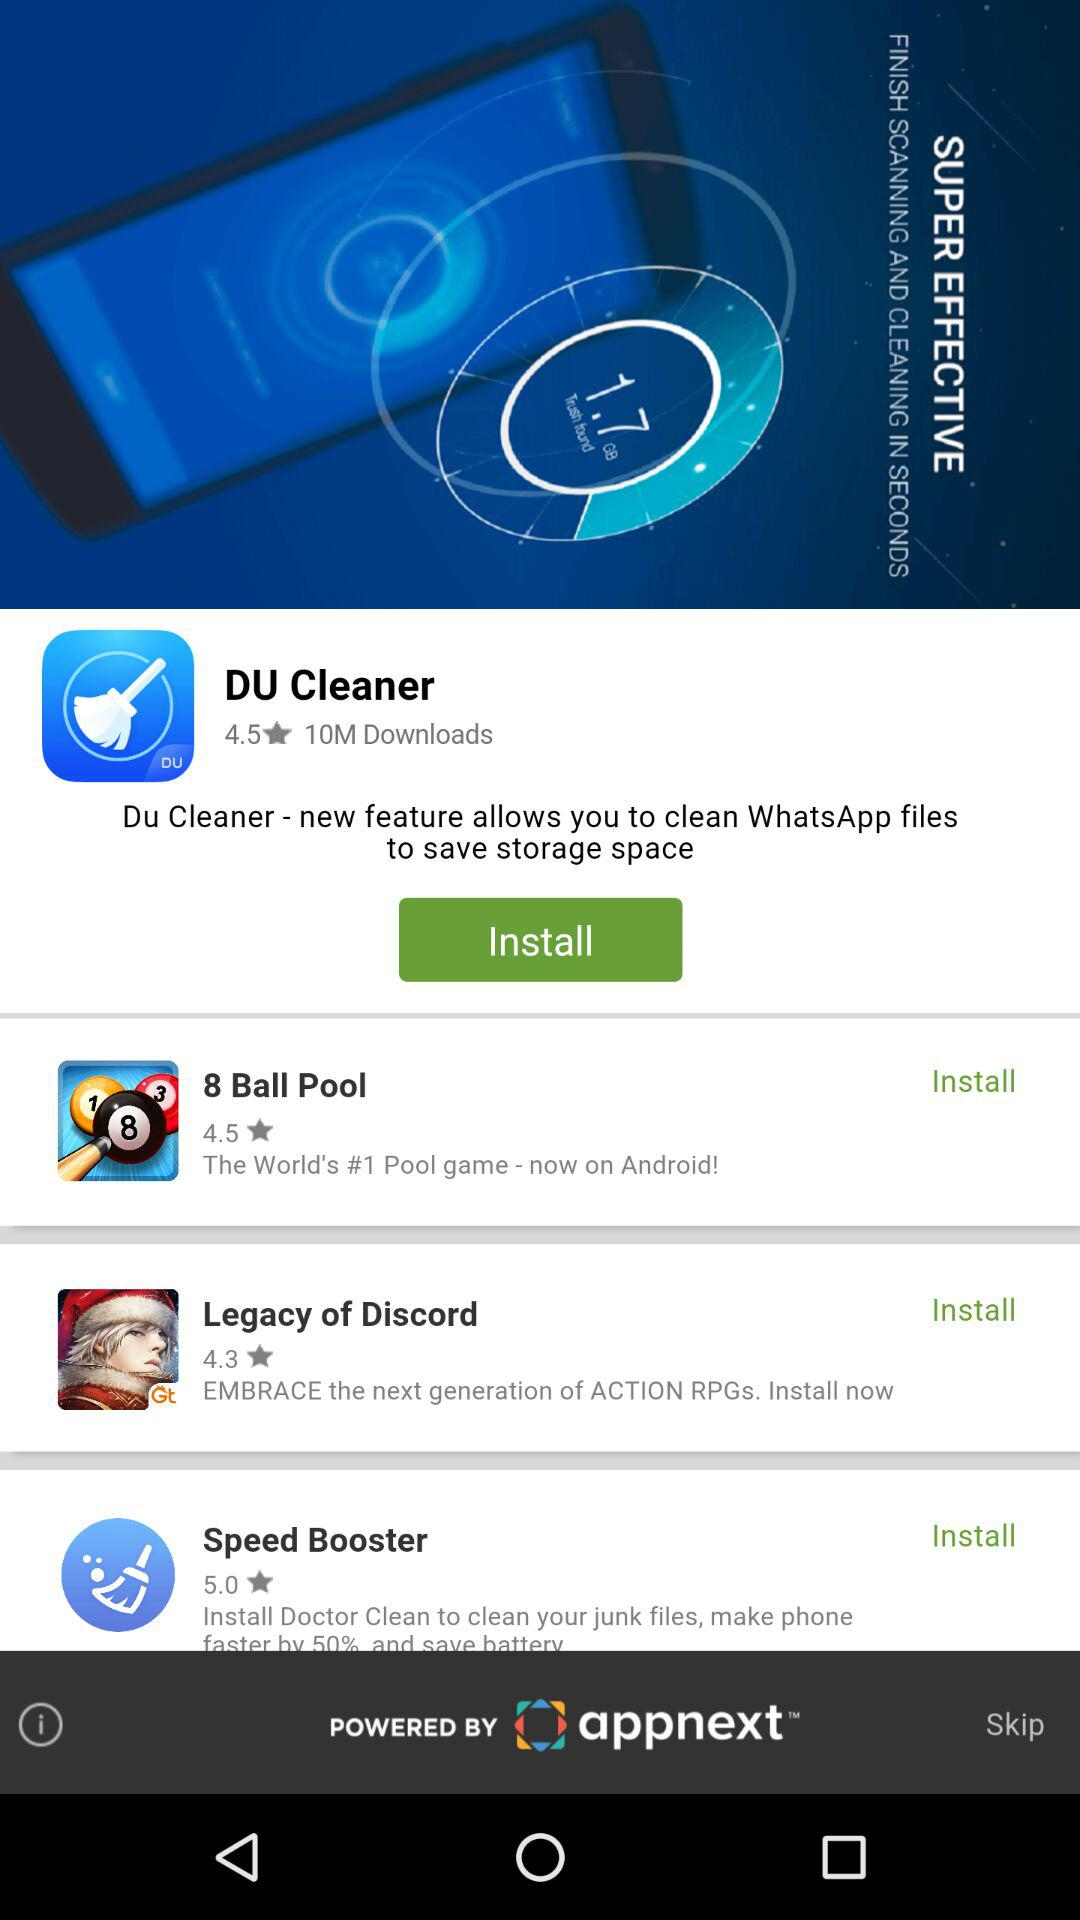What is the rating of a speed booster? The rating is 5 stars. 